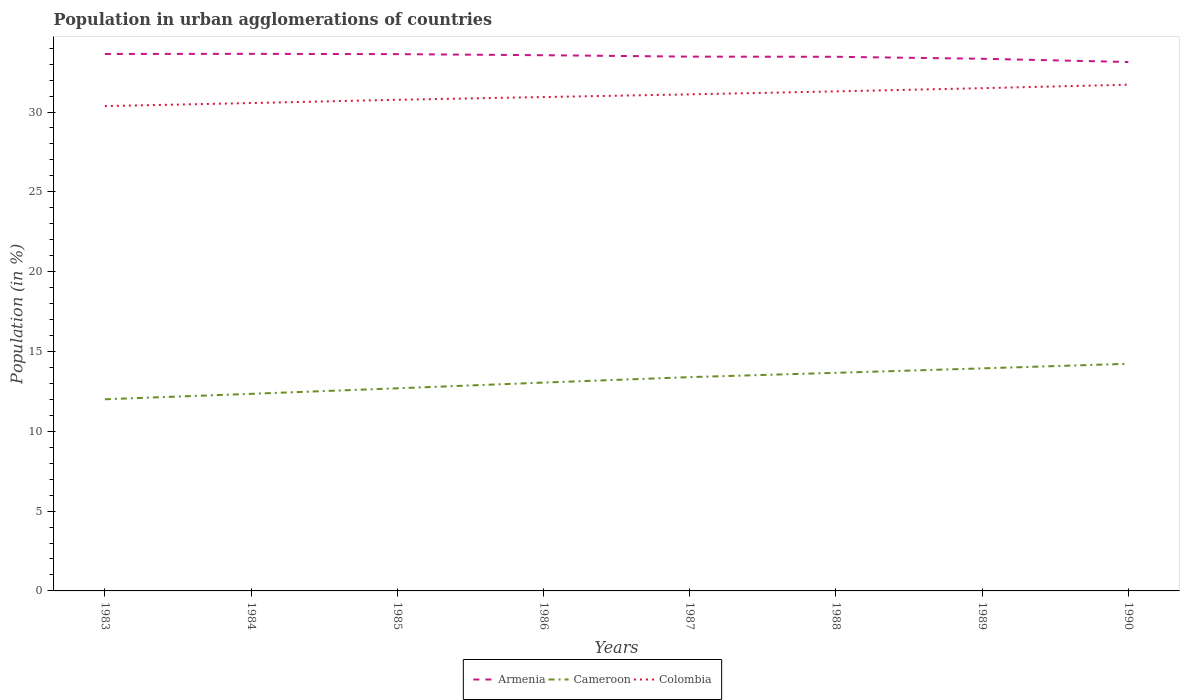Is the number of lines equal to the number of legend labels?
Your answer should be very brief. Yes. Across all years, what is the maximum percentage of population in urban agglomerations in Armenia?
Offer a very short reply. 33.13. In which year was the percentage of population in urban agglomerations in Cameroon maximum?
Your response must be concise. 1983. What is the total percentage of population in urban agglomerations in Armenia in the graph?
Offer a terse response. 0.09. What is the difference between the highest and the second highest percentage of population in urban agglomerations in Armenia?
Make the answer very short. 0.51. Is the percentage of population in urban agglomerations in Colombia strictly greater than the percentage of population in urban agglomerations in Armenia over the years?
Provide a succinct answer. Yes. How many years are there in the graph?
Your answer should be very brief. 8. How are the legend labels stacked?
Provide a succinct answer. Horizontal. What is the title of the graph?
Your answer should be compact. Population in urban agglomerations of countries. What is the label or title of the X-axis?
Keep it short and to the point. Years. What is the Population (in %) of Armenia in 1983?
Your answer should be very brief. 33.64. What is the Population (in %) of Cameroon in 1983?
Your response must be concise. 12.01. What is the Population (in %) in Colombia in 1983?
Your answer should be compact. 30.37. What is the Population (in %) in Armenia in 1984?
Give a very brief answer. 33.65. What is the Population (in %) of Cameroon in 1984?
Provide a short and direct response. 12.35. What is the Population (in %) of Colombia in 1984?
Make the answer very short. 30.56. What is the Population (in %) of Armenia in 1985?
Offer a very short reply. 33.63. What is the Population (in %) of Cameroon in 1985?
Your answer should be compact. 12.69. What is the Population (in %) of Colombia in 1985?
Give a very brief answer. 30.77. What is the Population (in %) of Armenia in 1986?
Make the answer very short. 33.56. What is the Population (in %) in Cameroon in 1986?
Give a very brief answer. 13.05. What is the Population (in %) in Colombia in 1986?
Ensure brevity in your answer.  30.94. What is the Population (in %) of Armenia in 1987?
Give a very brief answer. 33.47. What is the Population (in %) in Cameroon in 1987?
Provide a short and direct response. 13.39. What is the Population (in %) in Colombia in 1987?
Offer a terse response. 31.11. What is the Population (in %) of Armenia in 1988?
Keep it short and to the point. 33.46. What is the Population (in %) in Cameroon in 1988?
Your response must be concise. 13.66. What is the Population (in %) of Colombia in 1988?
Keep it short and to the point. 31.29. What is the Population (in %) of Armenia in 1989?
Your answer should be compact. 33.34. What is the Population (in %) of Cameroon in 1989?
Keep it short and to the point. 13.94. What is the Population (in %) of Colombia in 1989?
Offer a terse response. 31.49. What is the Population (in %) in Armenia in 1990?
Ensure brevity in your answer.  33.13. What is the Population (in %) in Cameroon in 1990?
Your answer should be very brief. 14.23. What is the Population (in %) in Colombia in 1990?
Your answer should be compact. 31.71. Across all years, what is the maximum Population (in %) of Armenia?
Your answer should be compact. 33.65. Across all years, what is the maximum Population (in %) of Cameroon?
Make the answer very short. 14.23. Across all years, what is the maximum Population (in %) in Colombia?
Provide a short and direct response. 31.71. Across all years, what is the minimum Population (in %) of Armenia?
Your answer should be compact. 33.13. Across all years, what is the minimum Population (in %) in Cameroon?
Give a very brief answer. 12.01. Across all years, what is the minimum Population (in %) in Colombia?
Provide a short and direct response. 30.37. What is the total Population (in %) of Armenia in the graph?
Make the answer very short. 267.87. What is the total Population (in %) in Cameroon in the graph?
Keep it short and to the point. 105.32. What is the total Population (in %) in Colombia in the graph?
Your answer should be compact. 248.25. What is the difference between the Population (in %) in Armenia in 1983 and that in 1984?
Keep it short and to the point. -0.01. What is the difference between the Population (in %) of Cameroon in 1983 and that in 1984?
Provide a succinct answer. -0.34. What is the difference between the Population (in %) in Colombia in 1983 and that in 1984?
Provide a succinct answer. -0.19. What is the difference between the Population (in %) of Armenia in 1983 and that in 1985?
Make the answer very short. 0.01. What is the difference between the Population (in %) in Cameroon in 1983 and that in 1985?
Your answer should be compact. -0.69. What is the difference between the Population (in %) in Colombia in 1983 and that in 1985?
Make the answer very short. -0.4. What is the difference between the Population (in %) in Armenia in 1983 and that in 1986?
Offer a terse response. 0.08. What is the difference between the Population (in %) of Cameroon in 1983 and that in 1986?
Make the answer very short. -1.04. What is the difference between the Population (in %) in Colombia in 1983 and that in 1986?
Your answer should be compact. -0.57. What is the difference between the Population (in %) in Armenia in 1983 and that in 1987?
Give a very brief answer. 0.17. What is the difference between the Population (in %) of Cameroon in 1983 and that in 1987?
Keep it short and to the point. -1.39. What is the difference between the Population (in %) in Colombia in 1983 and that in 1987?
Keep it short and to the point. -0.73. What is the difference between the Population (in %) of Armenia in 1983 and that in 1988?
Your response must be concise. 0.18. What is the difference between the Population (in %) in Cameroon in 1983 and that in 1988?
Make the answer very short. -1.66. What is the difference between the Population (in %) of Colombia in 1983 and that in 1988?
Make the answer very short. -0.92. What is the difference between the Population (in %) of Armenia in 1983 and that in 1989?
Keep it short and to the point. 0.3. What is the difference between the Population (in %) in Cameroon in 1983 and that in 1989?
Provide a short and direct response. -1.93. What is the difference between the Population (in %) of Colombia in 1983 and that in 1989?
Make the answer very short. -1.12. What is the difference between the Population (in %) in Armenia in 1983 and that in 1990?
Your answer should be compact. 0.5. What is the difference between the Population (in %) in Cameroon in 1983 and that in 1990?
Provide a short and direct response. -2.22. What is the difference between the Population (in %) of Colombia in 1983 and that in 1990?
Offer a very short reply. -1.34. What is the difference between the Population (in %) of Armenia in 1984 and that in 1985?
Provide a succinct answer. 0.02. What is the difference between the Population (in %) of Cameroon in 1984 and that in 1985?
Ensure brevity in your answer.  -0.35. What is the difference between the Population (in %) in Colombia in 1984 and that in 1985?
Provide a short and direct response. -0.21. What is the difference between the Population (in %) of Armenia in 1984 and that in 1986?
Provide a short and direct response. 0.09. What is the difference between the Population (in %) in Cameroon in 1984 and that in 1986?
Your answer should be very brief. -0.7. What is the difference between the Population (in %) of Colombia in 1984 and that in 1986?
Your answer should be compact. -0.38. What is the difference between the Population (in %) of Armenia in 1984 and that in 1987?
Ensure brevity in your answer.  0.17. What is the difference between the Population (in %) of Cameroon in 1984 and that in 1987?
Make the answer very short. -1.05. What is the difference between the Population (in %) in Colombia in 1984 and that in 1987?
Ensure brevity in your answer.  -0.54. What is the difference between the Population (in %) in Armenia in 1984 and that in 1988?
Your response must be concise. 0.18. What is the difference between the Population (in %) in Cameroon in 1984 and that in 1988?
Give a very brief answer. -1.32. What is the difference between the Population (in %) in Colombia in 1984 and that in 1988?
Your answer should be compact. -0.73. What is the difference between the Population (in %) in Armenia in 1984 and that in 1989?
Your answer should be compact. 0.31. What is the difference between the Population (in %) of Cameroon in 1984 and that in 1989?
Provide a short and direct response. -1.59. What is the difference between the Population (in %) of Colombia in 1984 and that in 1989?
Offer a very short reply. -0.93. What is the difference between the Population (in %) of Armenia in 1984 and that in 1990?
Your response must be concise. 0.51. What is the difference between the Population (in %) of Cameroon in 1984 and that in 1990?
Your answer should be compact. -1.88. What is the difference between the Population (in %) in Colombia in 1984 and that in 1990?
Your response must be concise. -1.15. What is the difference between the Population (in %) in Armenia in 1985 and that in 1986?
Give a very brief answer. 0.07. What is the difference between the Population (in %) of Cameroon in 1985 and that in 1986?
Ensure brevity in your answer.  -0.36. What is the difference between the Population (in %) in Colombia in 1985 and that in 1986?
Your response must be concise. -0.17. What is the difference between the Population (in %) of Armenia in 1985 and that in 1987?
Offer a very short reply. 0.16. What is the difference between the Population (in %) in Cameroon in 1985 and that in 1987?
Offer a terse response. -0.7. What is the difference between the Population (in %) of Colombia in 1985 and that in 1987?
Your answer should be compact. -0.34. What is the difference between the Population (in %) of Armenia in 1985 and that in 1988?
Make the answer very short. 0.17. What is the difference between the Population (in %) in Cameroon in 1985 and that in 1988?
Offer a terse response. -0.97. What is the difference between the Population (in %) of Colombia in 1985 and that in 1988?
Provide a short and direct response. -0.53. What is the difference between the Population (in %) in Armenia in 1985 and that in 1989?
Your answer should be compact. 0.29. What is the difference between the Population (in %) in Cameroon in 1985 and that in 1989?
Keep it short and to the point. -1.25. What is the difference between the Population (in %) of Colombia in 1985 and that in 1989?
Offer a very short reply. -0.73. What is the difference between the Population (in %) of Armenia in 1985 and that in 1990?
Provide a short and direct response. 0.49. What is the difference between the Population (in %) of Cameroon in 1985 and that in 1990?
Provide a succinct answer. -1.54. What is the difference between the Population (in %) of Colombia in 1985 and that in 1990?
Keep it short and to the point. -0.94. What is the difference between the Population (in %) of Armenia in 1986 and that in 1987?
Offer a terse response. 0.09. What is the difference between the Population (in %) of Cameroon in 1986 and that in 1987?
Your response must be concise. -0.34. What is the difference between the Population (in %) of Colombia in 1986 and that in 1987?
Your answer should be compact. -0.17. What is the difference between the Population (in %) of Armenia in 1986 and that in 1988?
Offer a very short reply. 0.1. What is the difference between the Population (in %) of Cameroon in 1986 and that in 1988?
Offer a terse response. -0.61. What is the difference between the Population (in %) of Colombia in 1986 and that in 1988?
Offer a very short reply. -0.35. What is the difference between the Population (in %) in Armenia in 1986 and that in 1989?
Make the answer very short. 0.22. What is the difference between the Population (in %) in Cameroon in 1986 and that in 1989?
Your answer should be very brief. -0.89. What is the difference between the Population (in %) in Colombia in 1986 and that in 1989?
Your answer should be very brief. -0.56. What is the difference between the Population (in %) of Armenia in 1986 and that in 1990?
Your response must be concise. 0.42. What is the difference between the Population (in %) of Cameroon in 1986 and that in 1990?
Offer a very short reply. -1.18. What is the difference between the Population (in %) in Colombia in 1986 and that in 1990?
Keep it short and to the point. -0.77. What is the difference between the Population (in %) of Armenia in 1987 and that in 1988?
Give a very brief answer. 0.01. What is the difference between the Population (in %) of Cameroon in 1987 and that in 1988?
Provide a succinct answer. -0.27. What is the difference between the Population (in %) of Colombia in 1987 and that in 1988?
Provide a succinct answer. -0.19. What is the difference between the Population (in %) in Armenia in 1987 and that in 1989?
Provide a short and direct response. 0.13. What is the difference between the Population (in %) in Cameroon in 1987 and that in 1989?
Offer a very short reply. -0.55. What is the difference between the Population (in %) of Colombia in 1987 and that in 1989?
Offer a terse response. -0.39. What is the difference between the Population (in %) in Armenia in 1987 and that in 1990?
Provide a short and direct response. 0.34. What is the difference between the Population (in %) of Cameroon in 1987 and that in 1990?
Make the answer very short. -0.84. What is the difference between the Population (in %) in Colombia in 1987 and that in 1990?
Your answer should be very brief. -0.61. What is the difference between the Population (in %) in Armenia in 1988 and that in 1989?
Offer a terse response. 0.12. What is the difference between the Population (in %) of Cameroon in 1988 and that in 1989?
Offer a very short reply. -0.28. What is the difference between the Population (in %) in Colombia in 1988 and that in 1989?
Keep it short and to the point. -0.2. What is the difference between the Population (in %) of Armenia in 1988 and that in 1990?
Your response must be concise. 0.33. What is the difference between the Population (in %) in Cameroon in 1988 and that in 1990?
Offer a very short reply. -0.57. What is the difference between the Population (in %) of Colombia in 1988 and that in 1990?
Give a very brief answer. -0.42. What is the difference between the Population (in %) in Armenia in 1989 and that in 1990?
Offer a terse response. 0.2. What is the difference between the Population (in %) in Cameroon in 1989 and that in 1990?
Ensure brevity in your answer.  -0.29. What is the difference between the Population (in %) of Colombia in 1989 and that in 1990?
Provide a succinct answer. -0.22. What is the difference between the Population (in %) of Armenia in 1983 and the Population (in %) of Cameroon in 1984?
Your answer should be very brief. 21.29. What is the difference between the Population (in %) in Armenia in 1983 and the Population (in %) in Colombia in 1984?
Your answer should be very brief. 3.07. What is the difference between the Population (in %) in Cameroon in 1983 and the Population (in %) in Colombia in 1984?
Ensure brevity in your answer.  -18.56. What is the difference between the Population (in %) of Armenia in 1983 and the Population (in %) of Cameroon in 1985?
Keep it short and to the point. 20.94. What is the difference between the Population (in %) in Armenia in 1983 and the Population (in %) in Colombia in 1985?
Provide a short and direct response. 2.87. What is the difference between the Population (in %) of Cameroon in 1983 and the Population (in %) of Colombia in 1985?
Keep it short and to the point. -18.76. What is the difference between the Population (in %) of Armenia in 1983 and the Population (in %) of Cameroon in 1986?
Provide a succinct answer. 20.59. What is the difference between the Population (in %) of Armenia in 1983 and the Population (in %) of Colombia in 1986?
Make the answer very short. 2.7. What is the difference between the Population (in %) in Cameroon in 1983 and the Population (in %) in Colombia in 1986?
Your response must be concise. -18.93. What is the difference between the Population (in %) in Armenia in 1983 and the Population (in %) in Cameroon in 1987?
Give a very brief answer. 20.24. What is the difference between the Population (in %) in Armenia in 1983 and the Population (in %) in Colombia in 1987?
Your answer should be very brief. 2.53. What is the difference between the Population (in %) of Cameroon in 1983 and the Population (in %) of Colombia in 1987?
Make the answer very short. -19.1. What is the difference between the Population (in %) in Armenia in 1983 and the Population (in %) in Cameroon in 1988?
Keep it short and to the point. 19.97. What is the difference between the Population (in %) in Armenia in 1983 and the Population (in %) in Colombia in 1988?
Your answer should be compact. 2.34. What is the difference between the Population (in %) in Cameroon in 1983 and the Population (in %) in Colombia in 1988?
Offer a very short reply. -19.29. What is the difference between the Population (in %) in Armenia in 1983 and the Population (in %) in Cameroon in 1989?
Make the answer very short. 19.7. What is the difference between the Population (in %) of Armenia in 1983 and the Population (in %) of Colombia in 1989?
Give a very brief answer. 2.14. What is the difference between the Population (in %) in Cameroon in 1983 and the Population (in %) in Colombia in 1989?
Offer a terse response. -19.49. What is the difference between the Population (in %) in Armenia in 1983 and the Population (in %) in Cameroon in 1990?
Your answer should be compact. 19.41. What is the difference between the Population (in %) of Armenia in 1983 and the Population (in %) of Colombia in 1990?
Make the answer very short. 1.93. What is the difference between the Population (in %) of Cameroon in 1983 and the Population (in %) of Colombia in 1990?
Keep it short and to the point. -19.71. What is the difference between the Population (in %) in Armenia in 1984 and the Population (in %) in Cameroon in 1985?
Provide a succinct answer. 20.95. What is the difference between the Population (in %) of Armenia in 1984 and the Population (in %) of Colombia in 1985?
Your answer should be compact. 2.88. What is the difference between the Population (in %) of Cameroon in 1984 and the Population (in %) of Colombia in 1985?
Provide a succinct answer. -18.42. What is the difference between the Population (in %) in Armenia in 1984 and the Population (in %) in Cameroon in 1986?
Give a very brief answer. 20.59. What is the difference between the Population (in %) in Armenia in 1984 and the Population (in %) in Colombia in 1986?
Your answer should be very brief. 2.71. What is the difference between the Population (in %) of Cameroon in 1984 and the Population (in %) of Colombia in 1986?
Your answer should be compact. -18.59. What is the difference between the Population (in %) of Armenia in 1984 and the Population (in %) of Cameroon in 1987?
Your answer should be compact. 20.25. What is the difference between the Population (in %) in Armenia in 1984 and the Population (in %) in Colombia in 1987?
Give a very brief answer. 2.54. What is the difference between the Population (in %) of Cameroon in 1984 and the Population (in %) of Colombia in 1987?
Your answer should be compact. -18.76. What is the difference between the Population (in %) of Armenia in 1984 and the Population (in %) of Cameroon in 1988?
Give a very brief answer. 19.98. What is the difference between the Population (in %) in Armenia in 1984 and the Population (in %) in Colombia in 1988?
Provide a short and direct response. 2.35. What is the difference between the Population (in %) of Cameroon in 1984 and the Population (in %) of Colombia in 1988?
Your response must be concise. -18.95. What is the difference between the Population (in %) of Armenia in 1984 and the Population (in %) of Cameroon in 1989?
Provide a succinct answer. 19.7. What is the difference between the Population (in %) of Armenia in 1984 and the Population (in %) of Colombia in 1989?
Offer a very short reply. 2.15. What is the difference between the Population (in %) of Cameroon in 1984 and the Population (in %) of Colombia in 1989?
Provide a succinct answer. -19.15. What is the difference between the Population (in %) in Armenia in 1984 and the Population (in %) in Cameroon in 1990?
Offer a terse response. 19.42. What is the difference between the Population (in %) in Armenia in 1984 and the Population (in %) in Colombia in 1990?
Ensure brevity in your answer.  1.93. What is the difference between the Population (in %) in Cameroon in 1984 and the Population (in %) in Colombia in 1990?
Your answer should be very brief. -19.37. What is the difference between the Population (in %) of Armenia in 1985 and the Population (in %) of Cameroon in 1986?
Give a very brief answer. 20.58. What is the difference between the Population (in %) of Armenia in 1985 and the Population (in %) of Colombia in 1986?
Your response must be concise. 2.69. What is the difference between the Population (in %) of Cameroon in 1985 and the Population (in %) of Colombia in 1986?
Offer a terse response. -18.25. What is the difference between the Population (in %) of Armenia in 1985 and the Population (in %) of Cameroon in 1987?
Offer a very short reply. 20.23. What is the difference between the Population (in %) in Armenia in 1985 and the Population (in %) in Colombia in 1987?
Offer a very short reply. 2.52. What is the difference between the Population (in %) in Cameroon in 1985 and the Population (in %) in Colombia in 1987?
Give a very brief answer. -18.41. What is the difference between the Population (in %) of Armenia in 1985 and the Population (in %) of Cameroon in 1988?
Offer a terse response. 19.96. What is the difference between the Population (in %) of Armenia in 1985 and the Population (in %) of Colombia in 1988?
Give a very brief answer. 2.33. What is the difference between the Population (in %) of Cameroon in 1985 and the Population (in %) of Colombia in 1988?
Give a very brief answer. -18.6. What is the difference between the Population (in %) in Armenia in 1985 and the Population (in %) in Cameroon in 1989?
Give a very brief answer. 19.69. What is the difference between the Population (in %) in Armenia in 1985 and the Population (in %) in Colombia in 1989?
Offer a terse response. 2.13. What is the difference between the Population (in %) of Cameroon in 1985 and the Population (in %) of Colombia in 1989?
Provide a succinct answer. -18.8. What is the difference between the Population (in %) of Armenia in 1985 and the Population (in %) of Cameroon in 1990?
Your answer should be compact. 19.4. What is the difference between the Population (in %) in Armenia in 1985 and the Population (in %) in Colombia in 1990?
Provide a short and direct response. 1.91. What is the difference between the Population (in %) in Cameroon in 1985 and the Population (in %) in Colombia in 1990?
Provide a succinct answer. -19.02. What is the difference between the Population (in %) of Armenia in 1986 and the Population (in %) of Cameroon in 1987?
Make the answer very short. 20.17. What is the difference between the Population (in %) in Armenia in 1986 and the Population (in %) in Colombia in 1987?
Give a very brief answer. 2.45. What is the difference between the Population (in %) of Cameroon in 1986 and the Population (in %) of Colombia in 1987?
Offer a terse response. -18.06. What is the difference between the Population (in %) in Armenia in 1986 and the Population (in %) in Cameroon in 1988?
Provide a short and direct response. 19.9. What is the difference between the Population (in %) in Armenia in 1986 and the Population (in %) in Colombia in 1988?
Ensure brevity in your answer.  2.27. What is the difference between the Population (in %) of Cameroon in 1986 and the Population (in %) of Colombia in 1988?
Offer a very short reply. -18.24. What is the difference between the Population (in %) in Armenia in 1986 and the Population (in %) in Cameroon in 1989?
Your answer should be very brief. 19.62. What is the difference between the Population (in %) of Armenia in 1986 and the Population (in %) of Colombia in 1989?
Provide a short and direct response. 2.06. What is the difference between the Population (in %) of Cameroon in 1986 and the Population (in %) of Colombia in 1989?
Give a very brief answer. -18.44. What is the difference between the Population (in %) in Armenia in 1986 and the Population (in %) in Cameroon in 1990?
Ensure brevity in your answer.  19.33. What is the difference between the Population (in %) of Armenia in 1986 and the Population (in %) of Colombia in 1990?
Ensure brevity in your answer.  1.85. What is the difference between the Population (in %) of Cameroon in 1986 and the Population (in %) of Colombia in 1990?
Offer a terse response. -18.66. What is the difference between the Population (in %) of Armenia in 1987 and the Population (in %) of Cameroon in 1988?
Provide a short and direct response. 19.81. What is the difference between the Population (in %) in Armenia in 1987 and the Population (in %) in Colombia in 1988?
Your answer should be compact. 2.18. What is the difference between the Population (in %) of Cameroon in 1987 and the Population (in %) of Colombia in 1988?
Give a very brief answer. -17.9. What is the difference between the Population (in %) in Armenia in 1987 and the Population (in %) in Cameroon in 1989?
Your answer should be compact. 19.53. What is the difference between the Population (in %) in Armenia in 1987 and the Population (in %) in Colombia in 1989?
Offer a terse response. 1.98. What is the difference between the Population (in %) in Cameroon in 1987 and the Population (in %) in Colombia in 1989?
Ensure brevity in your answer.  -18.1. What is the difference between the Population (in %) of Armenia in 1987 and the Population (in %) of Cameroon in 1990?
Offer a very short reply. 19.24. What is the difference between the Population (in %) of Armenia in 1987 and the Population (in %) of Colombia in 1990?
Your answer should be compact. 1.76. What is the difference between the Population (in %) of Cameroon in 1987 and the Population (in %) of Colombia in 1990?
Your answer should be very brief. -18.32. What is the difference between the Population (in %) of Armenia in 1988 and the Population (in %) of Cameroon in 1989?
Your answer should be very brief. 19.52. What is the difference between the Population (in %) of Armenia in 1988 and the Population (in %) of Colombia in 1989?
Keep it short and to the point. 1.97. What is the difference between the Population (in %) in Cameroon in 1988 and the Population (in %) in Colombia in 1989?
Your answer should be very brief. -17.83. What is the difference between the Population (in %) in Armenia in 1988 and the Population (in %) in Cameroon in 1990?
Make the answer very short. 19.23. What is the difference between the Population (in %) in Armenia in 1988 and the Population (in %) in Colombia in 1990?
Ensure brevity in your answer.  1.75. What is the difference between the Population (in %) in Cameroon in 1988 and the Population (in %) in Colombia in 1990?
Your answer should be compact. -18.05. What is the difference between the Population (in %) of Armenia in 1989 and the Population (in %) of Cameroon in 1990?
Your response must be concise. 19.11. What is the difference between the Population (in %) in Armenia in 1989 and the Population (in %) in Colombia in 1990?
Ensure brevity in your answer.  1.62. What is the difference between the Population (in %) of Cameroon in 1989 and the Population (in %) of Colombia in 1990?
Offer a terse response. -17.77. What is the average Population (in %) in Armenia per year?
Make the answer very short. 33.48. What is the average Population (in %) of Cameroon per year?
Offer a terse response. 13.17. What is the average Population (in %) of Colombia per year?
Provide a short and direct response. 31.03. In the year 1983, what is the difference between the Population (in %) in Armenia and Population (in %) in Cameroon?
Your answer should be compact. 21.63. In the year 1983, what is the difference between the Population (in %) of Armenia and Population (in %) of Colombia?
Make the answer very short. 3.27. In the year 1983, what is the difference between the Population (in %) of Cameroon and Population (in %) of Colombia?
Offer a terse response. -18.37. In the year 1984, what is the difference between the Population (in %) of Armenia and Population (in %) of Cameroon?
Your answer should be compact. 21.3. In the year 1984, what is the difference between the Population (in %) in Armenia and Population (in %) in Colombia?
Your answer should be compact. 3.08. In the year 1984, what is the difference between the Population (in %) of Cameroon and Population (in %) of Colombia?
Provide a short and direct response. -18.22. In the year 1985, what is the difference between the Population (in %) of Armenia and Population (in %) of Cameroon?
Provide a short and direct response. 20.93. In the year 1985, what is the difference between the Population (in %) in Armenia and Population (in %) in Colombia?
Your response must be concise. 2.86. In the year 1985, what is the difference between the Population (in %) of Cameroon and Population (in %) of Colombia?
Your response must be concise. -18.07. In the year 1986, what is the difference between the Population (in %) of Armenia and Population (in %) of Cameroon?
Keep it short and to the point. 20.51. In the year 1986, what is the difference between the Population (in %) in Armenia and Population (in %) in Colombia?
Ensure brevity in your answer.  2.62. In the year 1986, what is the difference between the Population (in %) of Cameroon and Population (in %) of Colombia?
Your answer should be very brief. -17.89. In the year 1987, what is the difference between the Population (in %) of Armenia and Population (in %) of Cameroon?
Keep it short and to the point. 20.08. In the year 1987, what is the difference between the Population (in %) in Armenia and Population (in %) in Colombia?
Provide a short and direct response. 2.36. In the year 1987, what is the difference between the Population (in %) of Cameroon and Population (in %) of Colombia?
Your answer should be compact. -17.71. In the year 1988, what is the difference between the Population (in %) of Armenia and Population (in %) of Cameroon?
Keep it short and to the point. 19.8. In the year 1988, what is the difference between the Population (in %) in Armenia and Population (in %) in Colombia?
Give a very brief answer. 2.17. In the year 1988, what is the difference between the Population (in %) in Cameroon and Population (in %) in Colombia?
Provide a short and direct response. -17.63. In the year 1989, what is the difference between the Population (in %) of Armenia and Population (in %) of Cameroon?
Your answer should be very brief. 19.4. In the year 1989, what is the difference between the Population (in %) of Armenia and Population (in %) of Colombia?
Provide a succinct answer. 1.84. In the year 1989, what is the difference between the Population (in %) of Cameroon and Population (in %) of Colombia?
Offer a very short reply. -17.55. In the year 1990, what is the difference between the Population (in %) in Armenia and Population (in %) in Cameroon?
Provide a short and direct response. 18.91. In the year 1990, what is the difference between the Population (in %) of Armenia and Population (in %) of Colombia?
Provide a short and direct response. 1.42. In the year 1990, what is the difference between the Population (in %) of Cameroon and Population (in %) of Colombia?
Your answer should be compact. -17.48. What is the ratio of the Population (in %) of Armenia in 1983 to that in 1984?
Your answer should be compact. 1. What is the ratio of the Population (in %) in Cameroon in 1983 to that in 1984?
Your answer should be very brief. 0.97. What is the ratio of the Population (in %) in Armenia in 1983 to that in 1985?
Offer a terse response. 1. What is the ratio of the Population (in %) of Cameroon in 1983 to that in 1985?
Make the answer very short. 0.95. What is the ratio of the Population (in %) of Colombia in 1983 to that in 1985?
Provide a succinct answer. 0.99. What is the ratio of the Population (in %) in Armenia in 1983 to that in 1986?
Provide a succinct answer. 1. What is the ratio of the Population (in %) of Colombia in 1983 to that in 1986?
Keep it short and to the point. 0.98. What is the ratio of the Population (in %) of Cameroon in 1983 to that in 1987?
Provide a short and direct response. 0.9. What is the ratio of the Population (in %) of Colombia in 1983 to that in 1987?
Give a very brief answer. 0.98. What is the ratio of the Population (in %) of Cameroon in 1983 to that in 1988?
Provide a short and direct response. 0.88. What is the ratio of the Population (in %) in Colombia in 1983 to that in 1988?
Offer a terse response. 0.97. What is the ratio of the Population (in %) in Cameroon in 1983 to that in 1989?
Offer a terse response. 0.86. What is the ratio of the Population (in %) of Colombia in 1983 to that in 1989?
Your answer should be very brief. 0.96. What is the ratio of the Population (in %) in Armenia in 1983 to that in 1990?
Provide a succinct answer. 1.02. What is the ratio of the Population (in %) of Cameroon in 1983 to that in 1990?
Give a very brief answer. 0.84. What is the ratio of the Population (in %) of Colombia in 1983 to that in 1990?
Make the answer very short. 0.96. What is the ratio of the Population (in %) in Armenia in 1984 to that in 1985?
Your answer should be compact. 1. What is the ratio of the Population (in %) of Cameroon in 1984 to that in 1985?
Your response must be concise. 0.97. What is the ratio of the Population (in %) of Armenia in 1984 to that in 1986?
Your response must be concise. 1. What is the ratio of the Population (in %) of Cameroon in 1984 to that in 1986?
Your answer should be compact. 0.95. What is the ratio of the Population (in %) in Colombia in 1984 to that in 1986?
Your answer should be very brief. 0.99. What is the ratio of the Population (in %) of Cameroon in 1984 to that in 1987?
Ensure brevity in your answer.  0.92. What is the ratio of the Population (in %) in Colombia in 1984 to that in 1987?
Keep it short and to the point. 0.98. What is the ratio of the Population (in %) in Armenia in 1984 to that in 1988?
Make the answer very short. 1.01. What is the ratio of the Population (in %) of Cameroon in 1984 to that in 1988?
Your response must be concise. 0.9. What is the ratio of the Population (in %) of Colombia in 1984 to that in 1988?
Your answer should be very brief. 0.98. What is the ratio of the Population (in %) in Armenia in 1984 to that in 1989?
Your response must be concise. 1.01. What is the ratio of the Population (in %) in Cameroon in 1984 to that in 1989?
Provide a succinct answer. 0.89. What is the ratio of the Population (in %) of Colombia in 1984 to that in 1989?
Give a very brief answer. 0.97. What is the ratio of the Population (in %) in Armenia in 1984 to that in 1990?
Keep it short and to the point. 1.02. What is the ratio of the Population (in %) of Cameroon in 1984 to that in 1990?
Give a very brief answer. 0.87. What is the ratio of the Population (in %) of Colombia in 1984 to that in 1990?
Your answer should be compact. 0.96. What is the ratio of the Population (in %) in Armenia in 1985 to that in 1986?
Keep it short and to the point. 1. What is the ratio of the Population (in %) of Cameroon in 1985 to that in 1986?
Your answer should be compact. 0.97. What is the ratio of the Population (in %) in Armenia in 1985 to that in 1987?
Provide a succinct answer. 1. What is the ratio of the Population (in %) in Cameroon in 1985 to that in 1987?
Ensure brevity in your answer.  0.95. What is the ratio of the Population (in %) in Cameroon in 1985 to that in 1988?
Your response must be concise. 0.93. What is the ratio of the Population (in %) in Colombia in 1985 to that in 1988?
Provide a succinct answer. 0.98. What is the ratio of the Population (in %) of Armenia in 1985 to that in 1989?
Ensure brevity in your answer.  1.01. What is the ratio of the Population (in %) in Cameroon in 1985 to that in 1989?
Give a very brief answer. 0.91. What is the ratio of the Population (in %) in Colombia in 1985 to that in 1989?
Ensure brevity in your answer.  0.98. What is the ratio of the Population (in %) of Armenia in 1985 to that in 1990?
Offer a very short reply. 1.01. What is the ratio of the Population (in %) of Cameroon in 1985 to that in 1990?
Your response must be concise. 0.89. What is the ratio of the Population (in %) of Colombia in 1985 to that in 1990?
Your answer should be very brief. 0.97. What is the ratio of the Population (in %) of Cameroon in 1986 to that in 1987?
Offer a very short reply. 0.97. What is the ratio of the Population (in %) of Armenia in 1986 to that in 1988?
Offer a terse response. 1. What is the ratio of the Population (in %) of Cameroon in 1986 to that in 1988?
Provide a short and direct response. 0.96. What is the ratio of the Population (in %) of Colombia in 1986 to that in 1988?
Ensure brevity in your answer.  0.99. What is the ratio of the Population (in %) of Armenia in 1986 to that in 1989?
Provide a short and direct response. 1.01. What is the ratio of the Population (in %) of Cameroon in 1986 to that in 1989?
Your answer should be compact. 0.94. What is the ratio of the Population (in %) in Colombia in 1986 to that in 1989?
Provide a succinct answer. 0.98. What is the ratio of the Population (in %) in Armenia in 1986 to that in 1990?
Your answer should be compact. 1.01. What is the ratio of the Population (in %) in Cameroon in 1986 to that in 1990?
Offer a very short reply. 0.92. What is the ratio of the Population (in %) in Colombia in 1986 to that in 1990?
Provide a short and direct response. 0.98. What is the ratio of the Population (in %) in Cameroon in 1987 to that in 1988?
Provide a short and direct response. 0.98. What is the ratio of the Population (in %) in Cameroon in 1987 to that in 1989?
Provide a short and direct response. 0.96. What is the ratio of the Population (in %) in Colombia in 1987 to that in 1989?
Provide a succinct answer. 0.99. What is the ratio of the Population (in %) of Armenia in 1987 to that in 1990?
Provide a succinct answer. 1.01. What is the ratio of the Population (in %) in Cameroon in 1987 to that in 1990?
Keep it short and to the point. 0.94. What is the ratio of the Population (in %) in Colombia in 1987 to that in 1990?
Keep it short and to the point. 0.98. What is the ratio of the Population (in %) of Armenia in 1988 to that in 1989?
Offer a very short reply. 1. What is the ratio of the Population (in %) in Cameroon in 1988 to that in 1989?
Your answer should be compact. 0.98. What is the ratio of the Population (in %) of Colombia in 1988 to that in 1989?
Your answer should be very brief. 0.99. What is the ratio of the Population (in %) of Armenia in 1988 to that in 1990?
Your response must be concise. 1.01. What is the ratio of the Population (in %) in Cameroon in 1988 to that in 1990?
Give a very brief answer. 0.96. What is the ratio of the Population (in %) of Colombia in 1988 to that in 1990?
Your answer should be compact. 0.99. What is the ratio of the Population (in %) in Armenia in 1989 to that in 1990?
Offer a very short reply. 1.01. What is the ratio of the Population (in %) in Cameroon in 1989 to that in 1990?
Offer a very short reply. 0.98. What is the difference between the highest and the second highest Population (in %) in Armenia?
Your answer should be compact. 0.01. What is the difference between the highest and the second highest Population (in %) of Cameroon?
Your response must be concise. 0.29. What is the difference between the highest and the second highest Population (in %) of Colombia?
Your answer should be very brief. 0.22. What is the difference between the highest and the lowest Population (in %) in Armenia?
Offer a very short reply. 0.51. What is the difference between the highest and the lowest Population (in %) in Cameroon?
Provide a short and direct response. 2.22. What is the difference between the highest and the lowest Population (in %) in Colombia?
Keep it short and to the point. 1.34. 